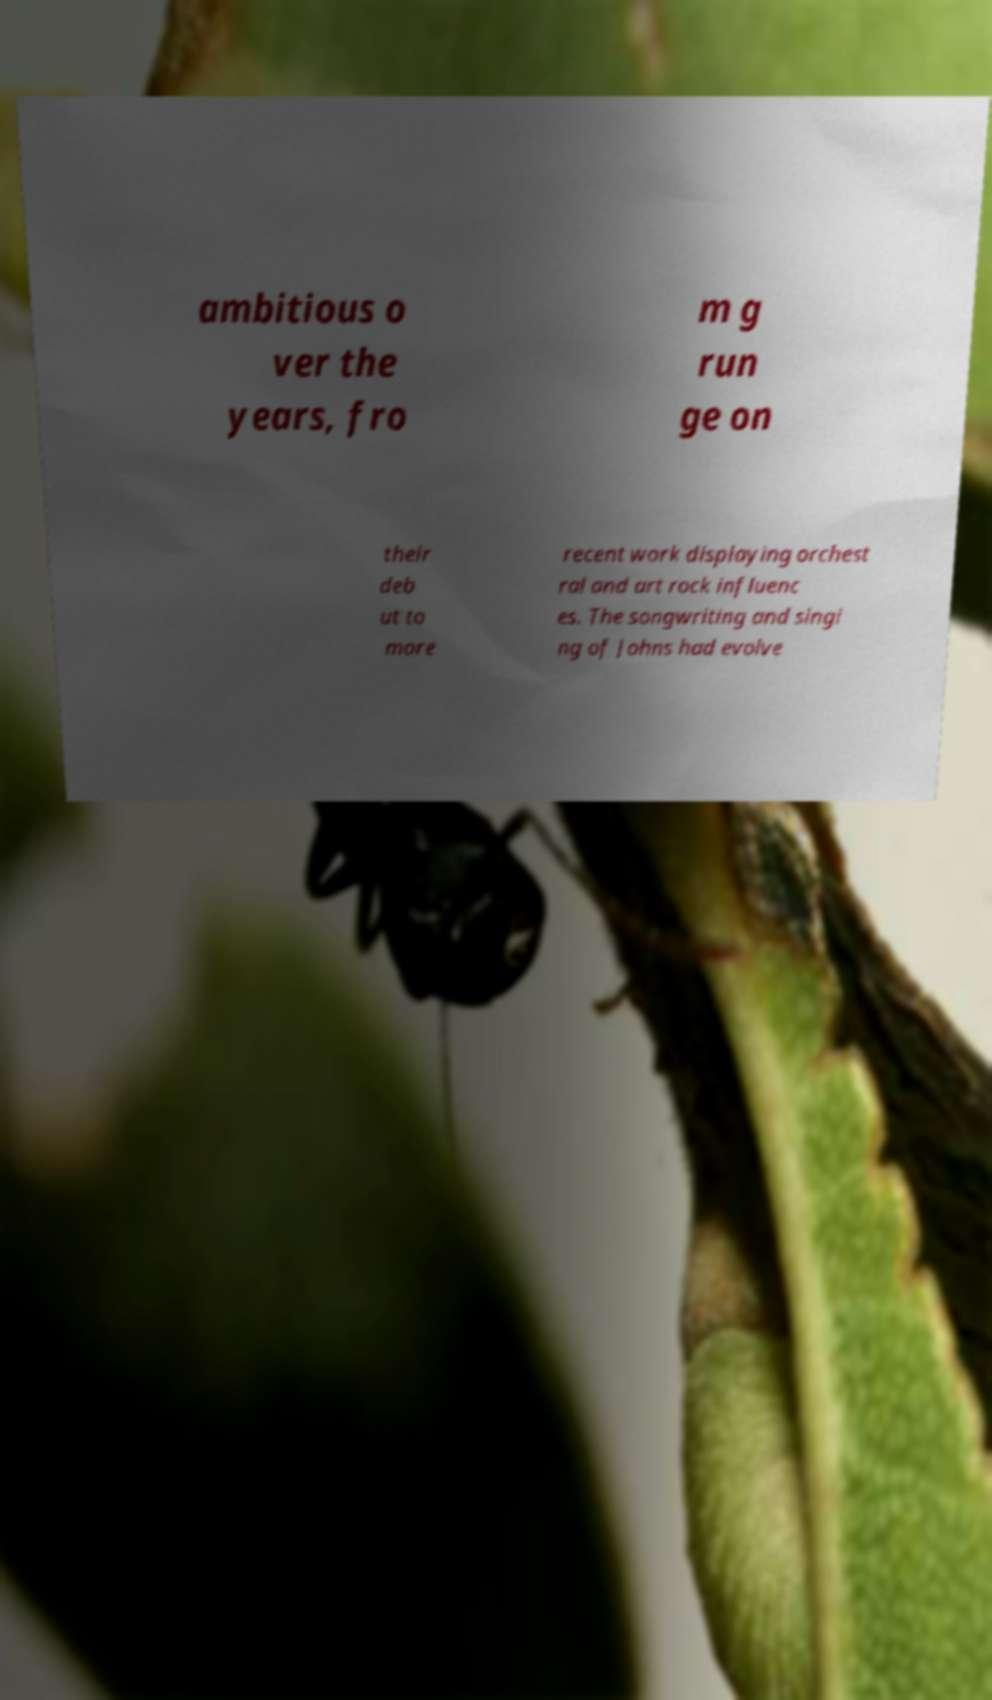Please identify and transcribe the text found in this image. ambitious o ver the years, fro m g run ge on their deb ut to more recent work displaying orchest ral and art rock influenc es. The songwriting and singi ng of Johns had evolve 